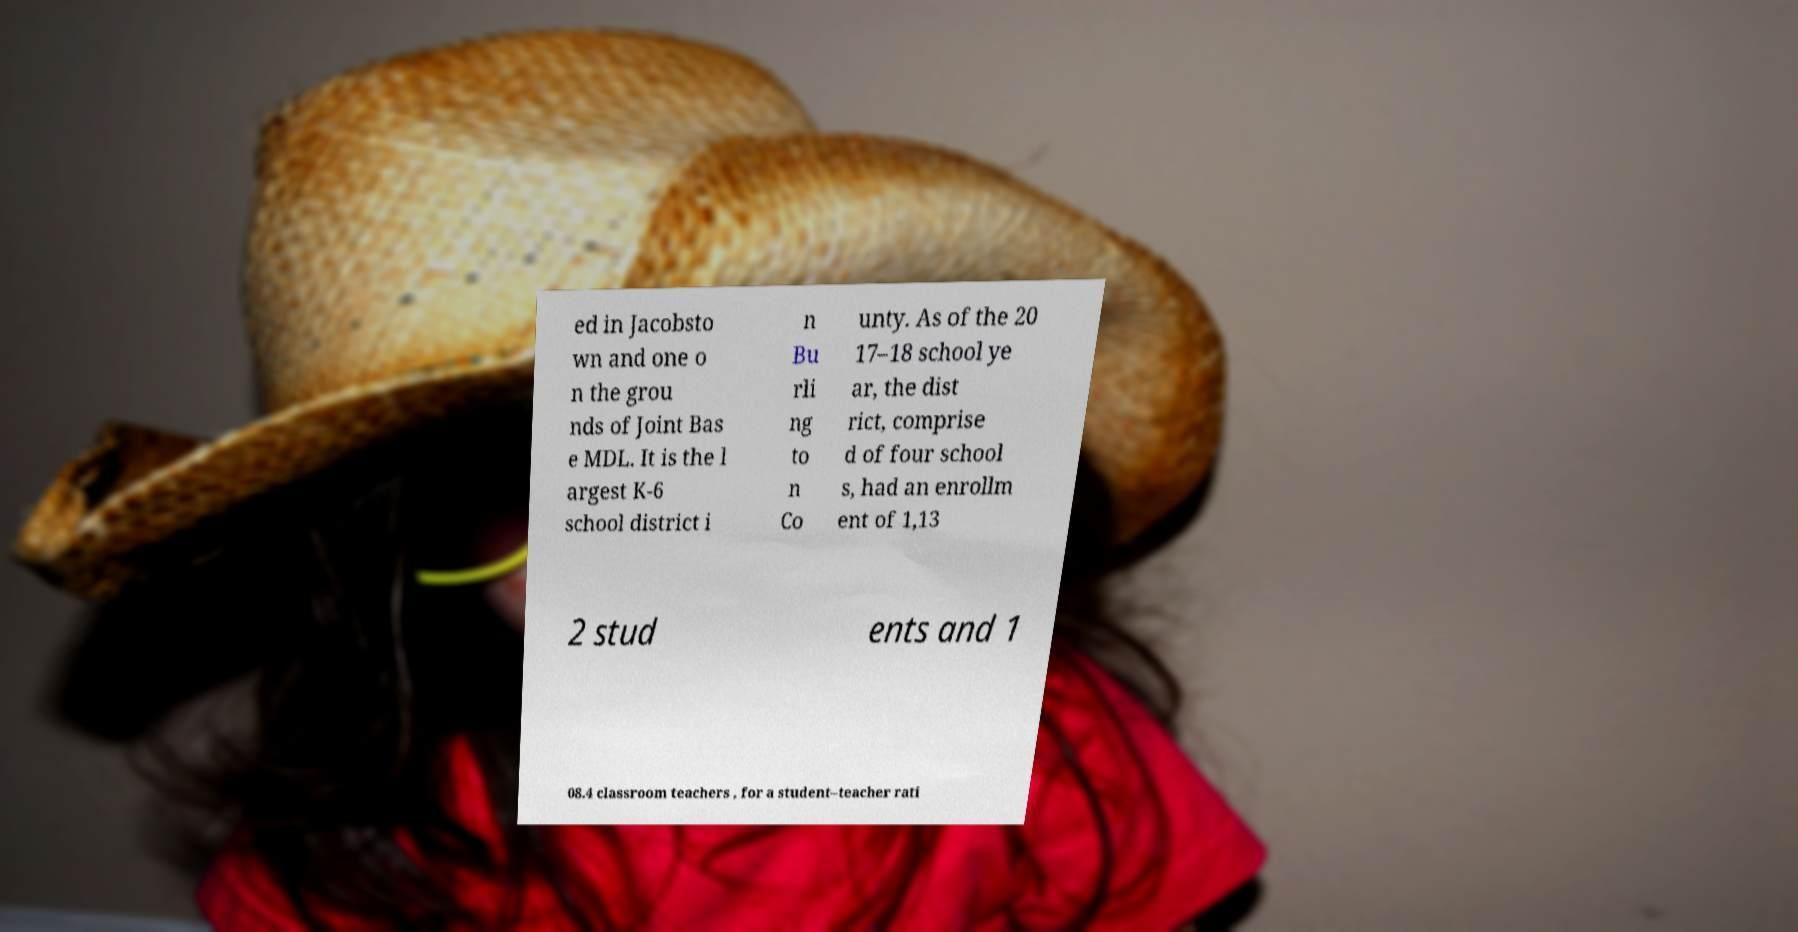There's text embedded in this image that I need extracted. Can you transcribe it verbatim? ed in Jacobsto wn and one o n the grou nds of Joint Bas e MDL. It is the l argest K-6 school district i n Bu rli ng to n Co unty. As of the 20 17–18 school ye ar, the dist rict, comprise d of four school s, had an enrollm ent of 1,13 2 stud ents and 1 08.4 classroom teachers , for a student–teacher rati 